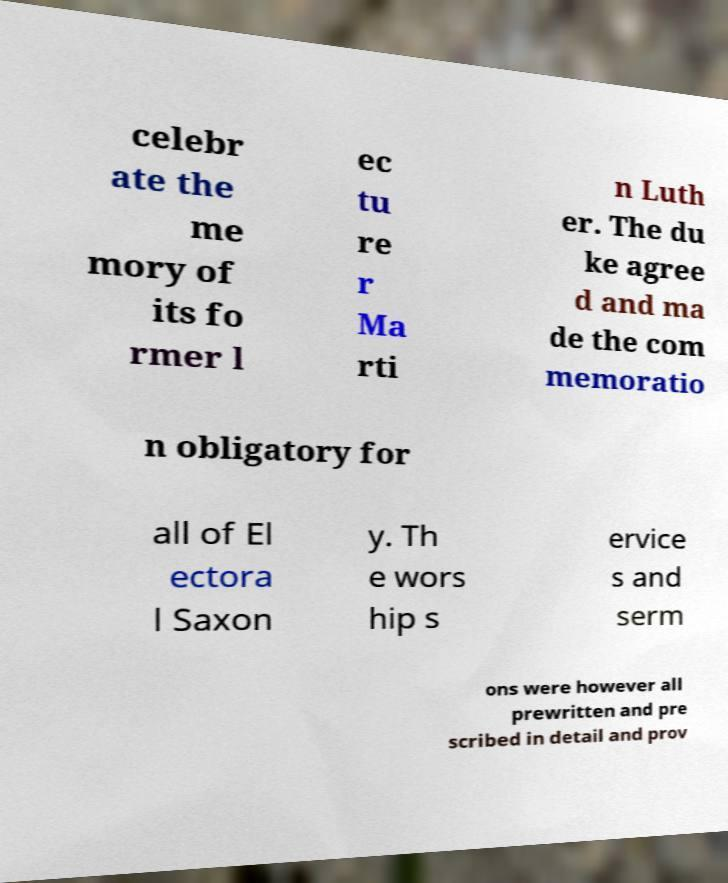Can you accurately transcribe the text from the provided image for me? celebr ate the me mory of its fo rmer l ec tu re r Ma rti n Luth er. The du ke agree d and ma de the com memoratio n obligatory for all of El ectora l Saxon y. Th e wors hip s ervice s and serm ons were however all prewritten and pre scribed in detail and prov 